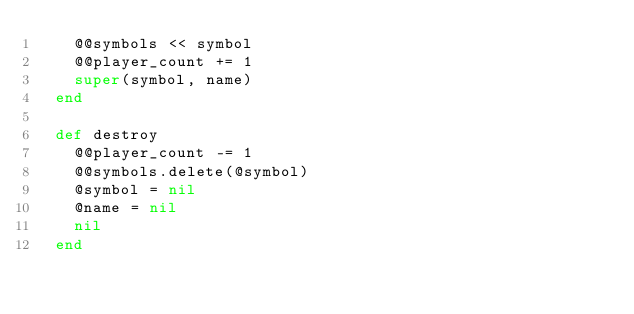Convert code to text. <code><loc_0><loc_0><loc_500><loc_500><_Ruby_>    @@symbols << symbol
    @@player_count += 1
    super(symbol, name)
  end

  def destroy
    @@player_count -= 1
    @@symbols.delete(@symbol)
    @symbol = nil
    @name = nil
    nil
  end
</code> 